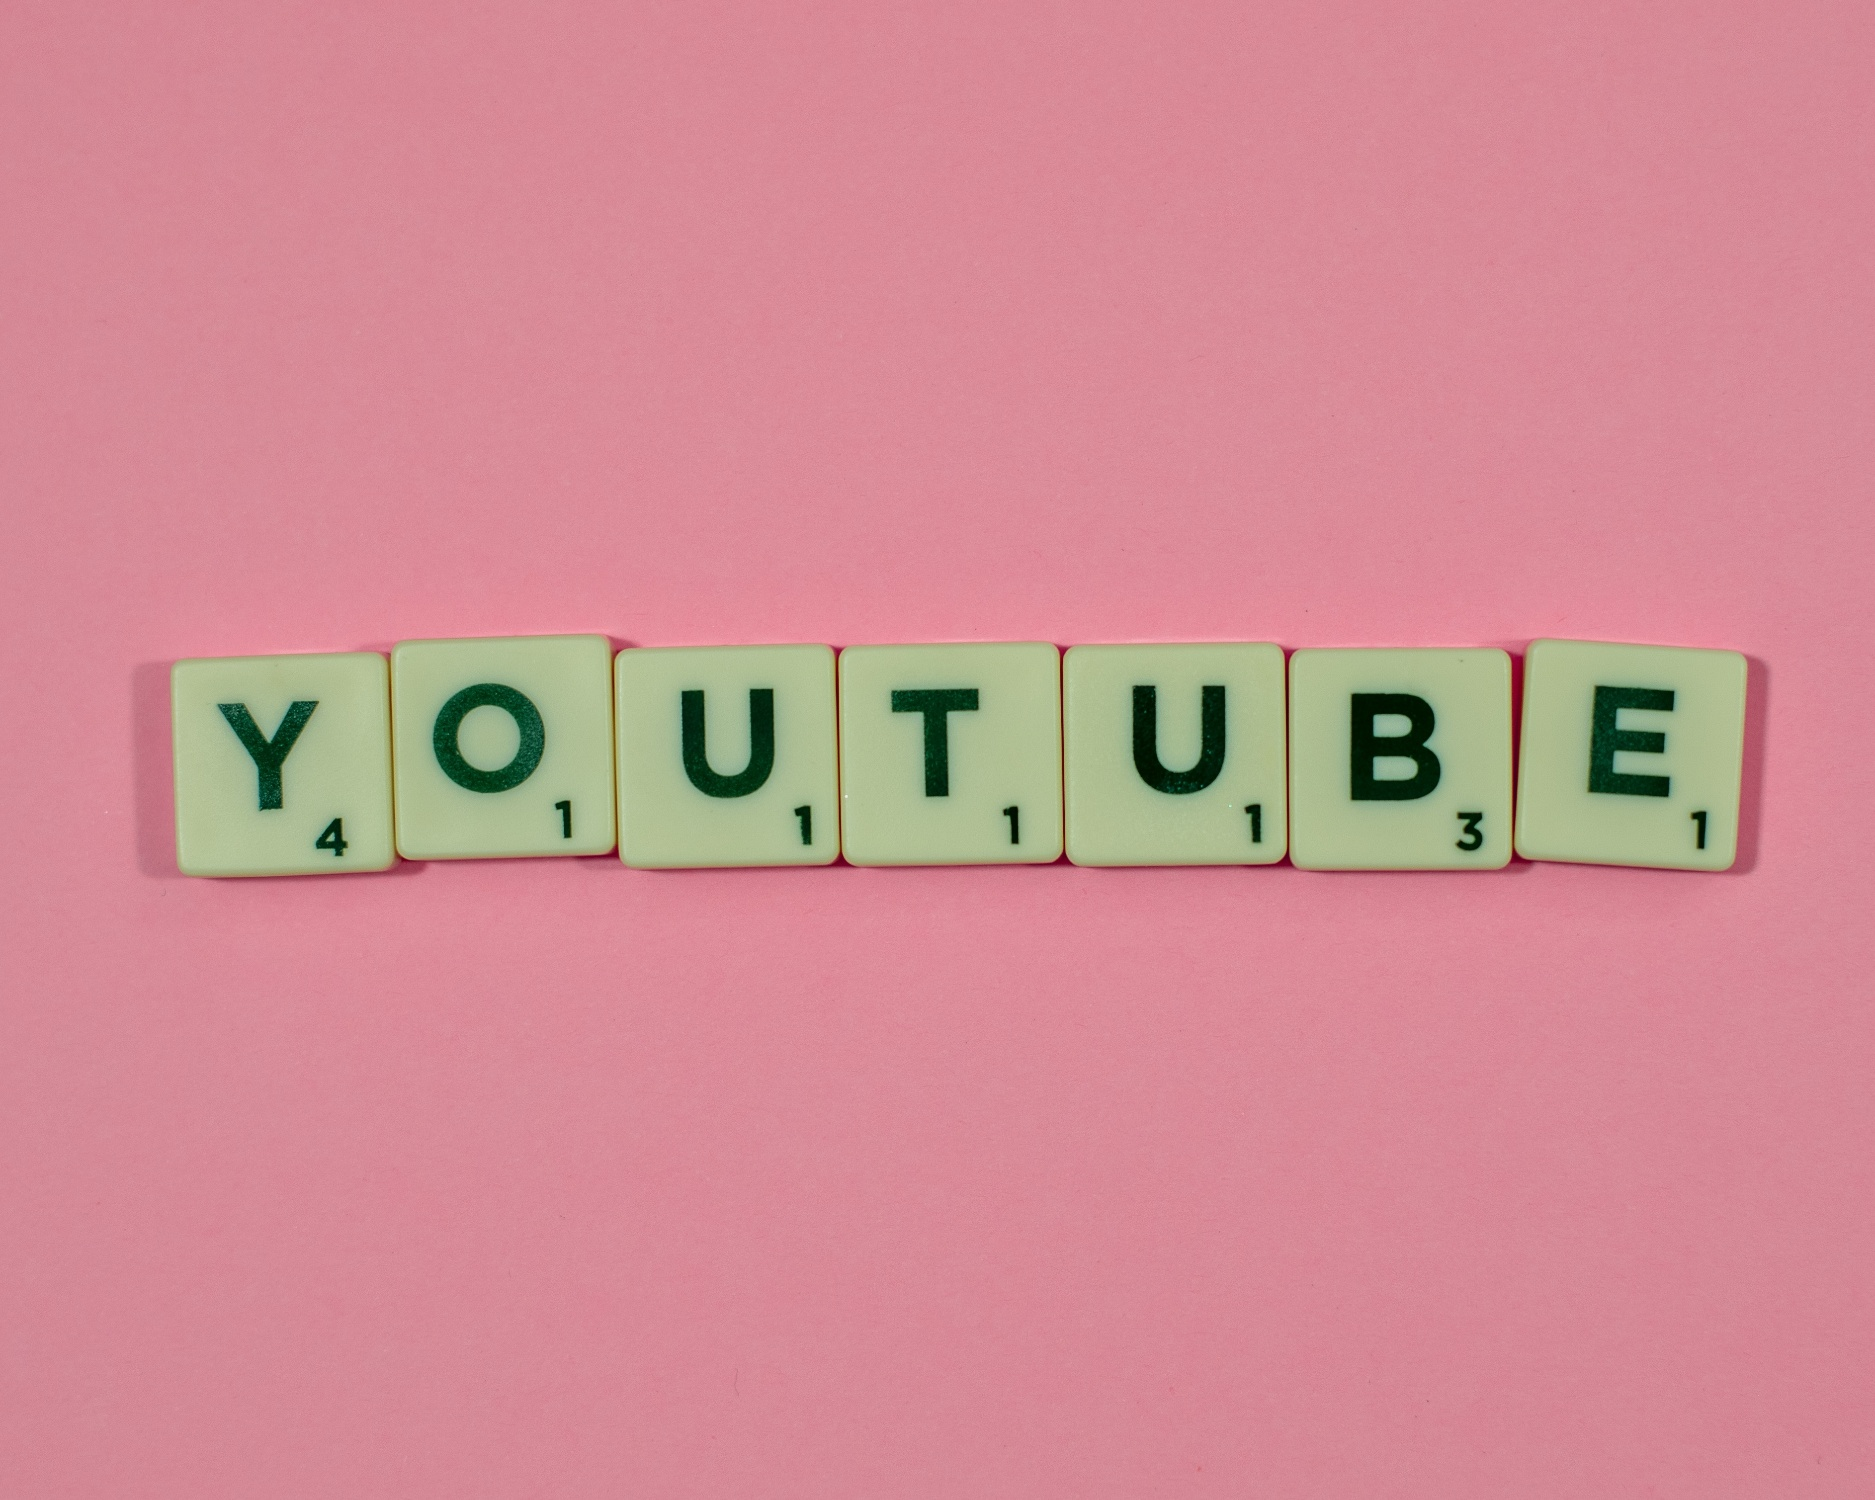What are the key elements in this picture? The picture showcases a creative scene set against a vivid pink background. Central to the image is a row of Scrabble tiles, each in a light green shade with black lettering. The tiles spell out the word 'YOUTUBE,' with each letter perfectly aligned in a straight line from left to right: 'Y,' 'O,' 'U,' 'T,' 'U,' 'B,' 'E.' Additionally, each tile features a number in the bottom right corner, corresponding to the letter's point value in Scrabble. The combination of the vibrant backdrop, the familiar game pieces, and the recognizable word evokes a playful and creative association with the popular video-sharing platform, YouTube. 